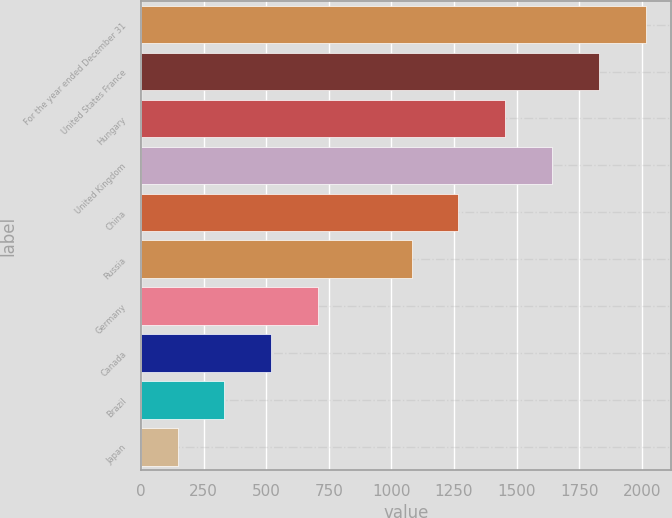Convert chart to OTSL. <chart><loc_0><loc_0><loc_500><loc_500><bar_chart><fcel>For the year ended December 31<fcel>United States France<fcel>Hungary<fcel>United Kingdom<fcel>China<fcel>Russia<fcel>Germany<fcel>Canada<fcel>Brazil<fcel>Japan<nl><fcel>2016<fcel>1828.9<fcel>1454.7<fcel>1641.8<fcel>1267.6<fcel>1080.5<fcel>706.3<fcel>519.2<fcel>332.1<fcel>145<nl></chart> 